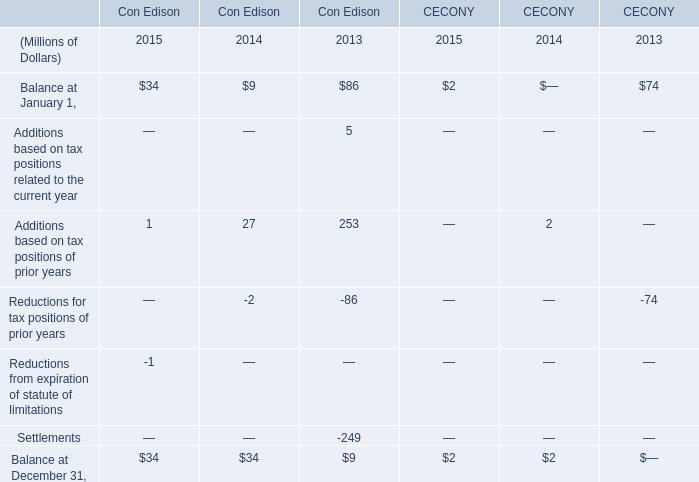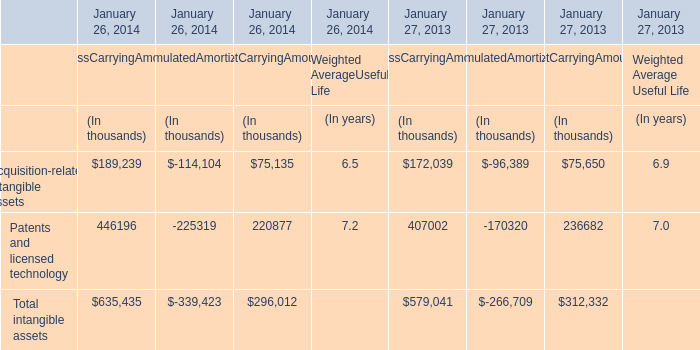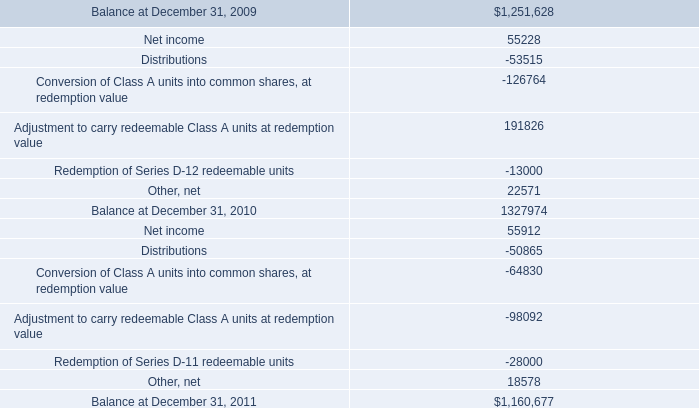What will Balance at January 1 of Con Edison reach in 2016 if it continues to grow at its 2015 rate? (in million) 
Computations: (34 * (1 + ((34 - 9) / 9)))
Answer: 128.44444. 